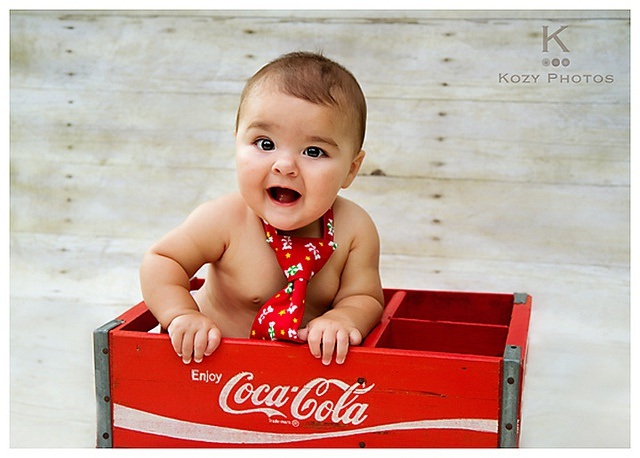Describe the objects in this image and their specific colors. I can see people in white, tan, salmon, and brown tones and tie in white, red, brown, and maroon tones in this image. 